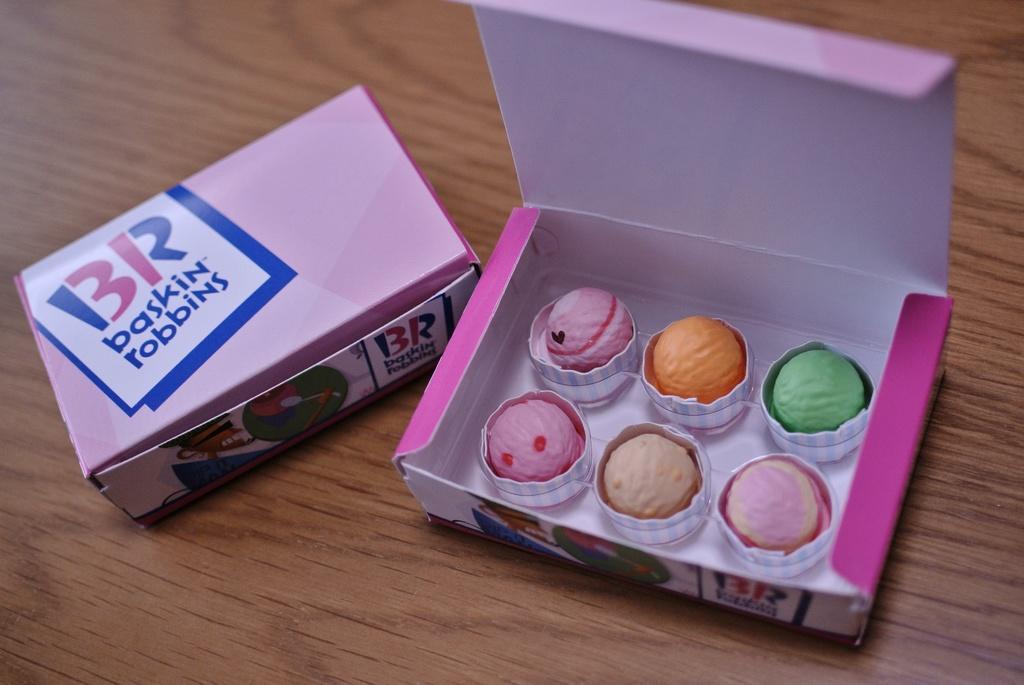How would you summarize this image in a sentence or two? In this image I can see two boxes on a wooden table I can see one box is opened and another is closed. I can see some ice creams in the open box I can see some text in the closed box. 